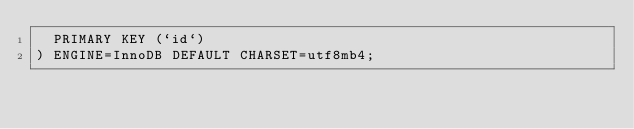<code> <loc_0><loc_0><loc_500><loc_500><_SQL_>  PRIMARY KEY (`id`)
) ENGINE=InnoDB DEFAULT CHARSET=utf8mb4;
</code> 